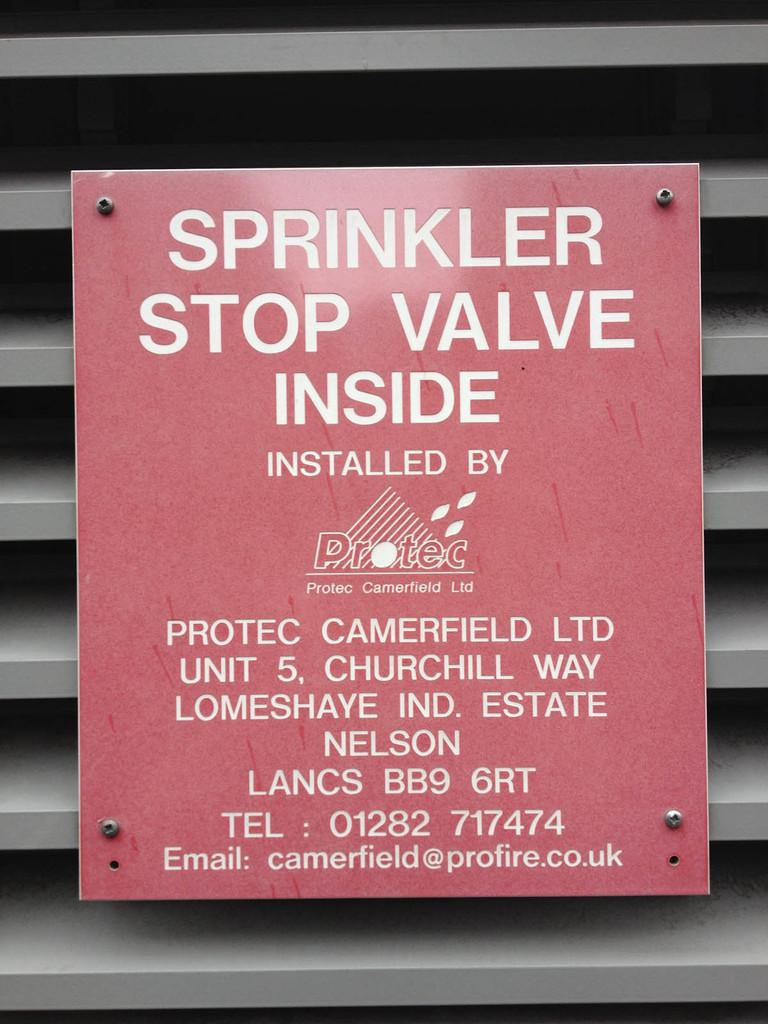<image>
Provide a brief description of the given image. an informative sign in red about a sprinkler stop valve being inside and who installed it 